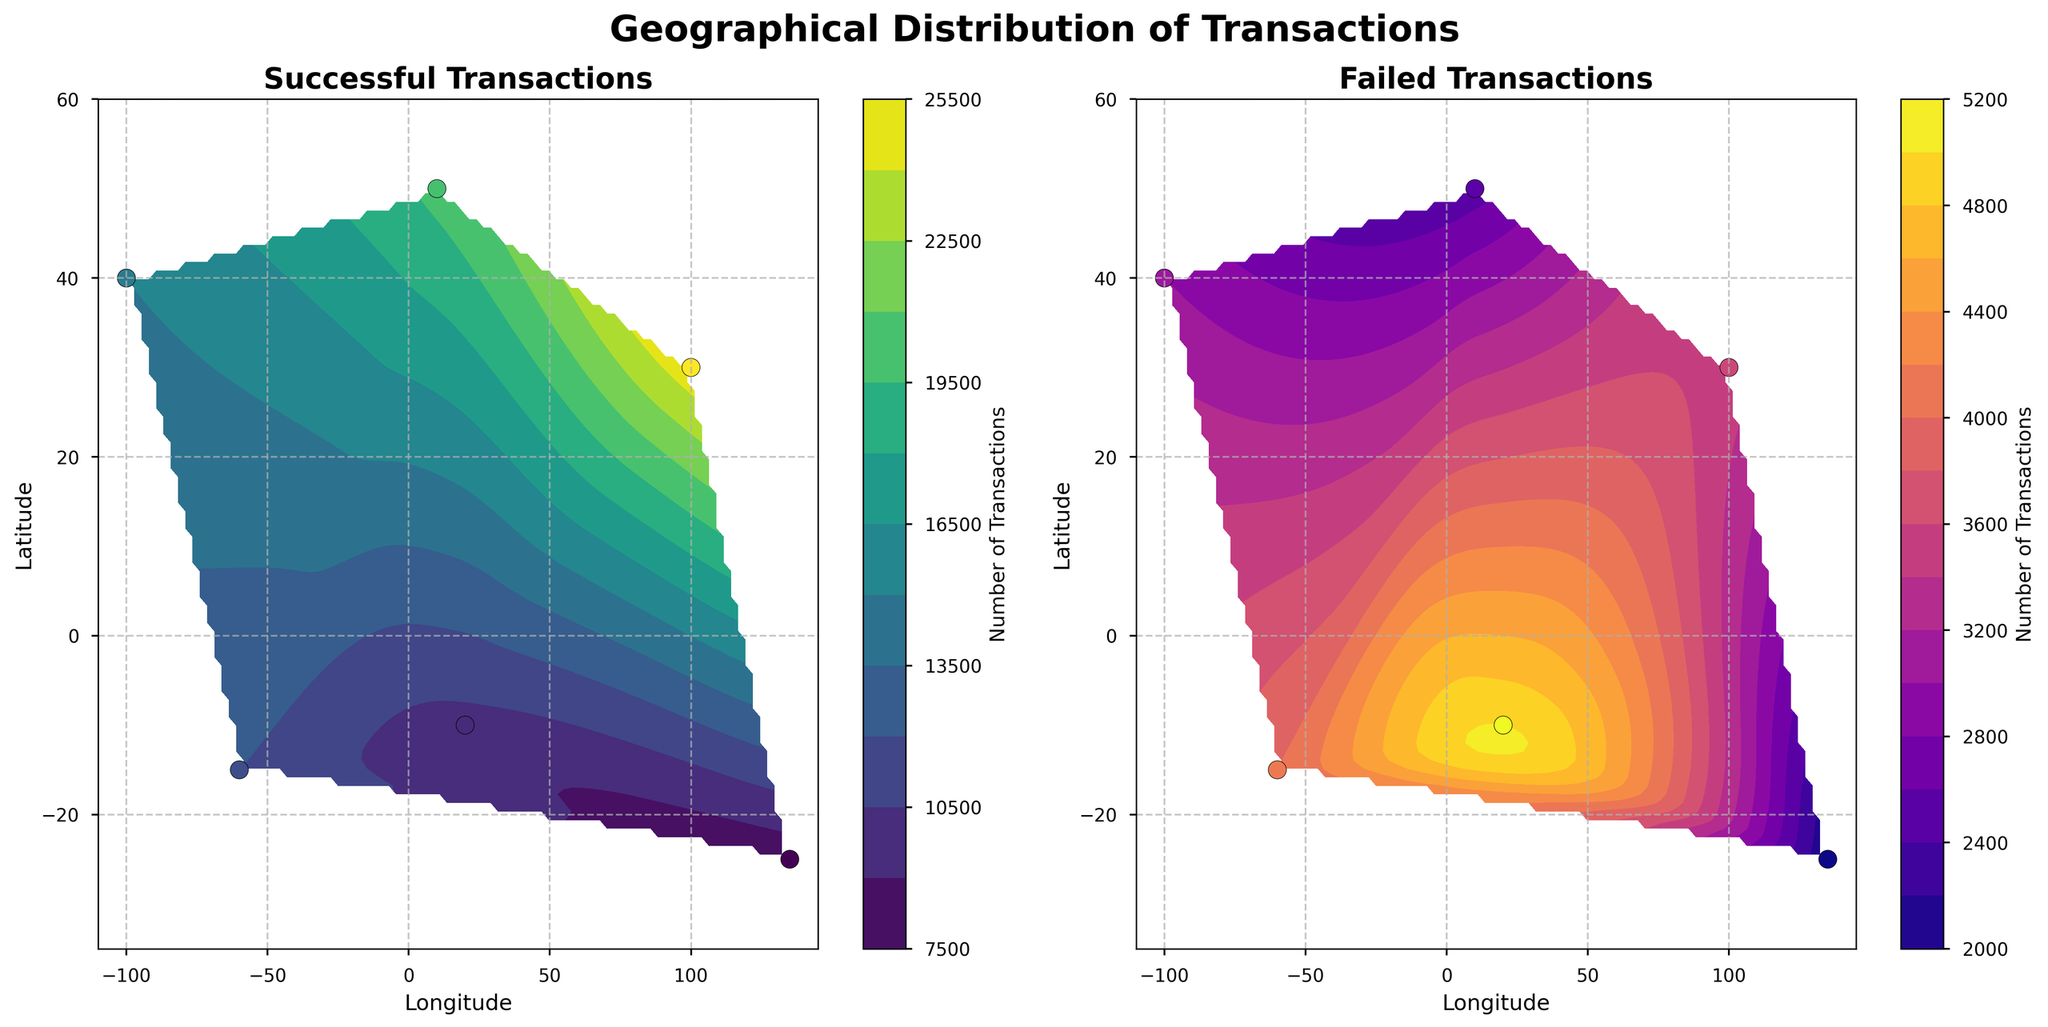What is the title of the subplot for the first contour plot on the left? The title of the subplot for the first contour plot on the left is indicated at the top center of the contour plot.
Answer: Successful Transactions How many data points are used in each of the contour plots? The figure shows a scatter plot overlaid on the contour plots with distinct points representing the data. Counting these points reveals the number of data points. There are 6 data points visible in both contour plots.
Answer: 6 Which region has the highest number of successful transactions? On the left contour plot, the color intensity indicates the number of successful transactions, with higher intensity representing higher values. Additionally, the scatter points also show values. Asia (located at (100.0, 30.0)) has the highest value of 25,000 successful transactions.
Answer: Asia Which region has the highest number of failed transactions? On the right contour plot, the color intensity indicates the number of failed transactions with higher intensity representing higher values, and the scatter points show the values as well. Africa (located at (20.0, -10.0)) has the highest value of 5,000 failed transactions.
Answer: Africa What are the color scales used for the successful and failed transactions? The color scales are indicated by the color bar on the right side of each subplot. The successful transactions use the 'viridis' colormap, which ranges from dark purple to yellow-green. The failed transactions use the 'plasma' colormap, which ranges from purple to yellow-orange.
Answer: 'viridis' for successful and 'plasma' for failed Which region appears to have nearly equal numbers of successful and failed transactions? By comparing the scatter point values across both contour plots, observe the points with values that are close for both successful and failed transactions. South America (located at (-60.0, -15.0)) has 12,000 successful and 4,000 failed transactions, which are relatively closely comparable.
Answer: South America Which region has the smallest number of failed transactions, and what is that number? On the right contour plot showing failed transactions, the color intensity and scatter points reveal values. Australia (located at (135.0, -25.0)) has the smallest number of failed transactions with a value of 2,000.
Answer: Australia What is the total number of transactions (successful plus failed) for North America? By summing the successful and failed transactions for North America, 15,000 (successful) + 3,000 (failed) = 18,000 total transactions.
Answer: 18,000 